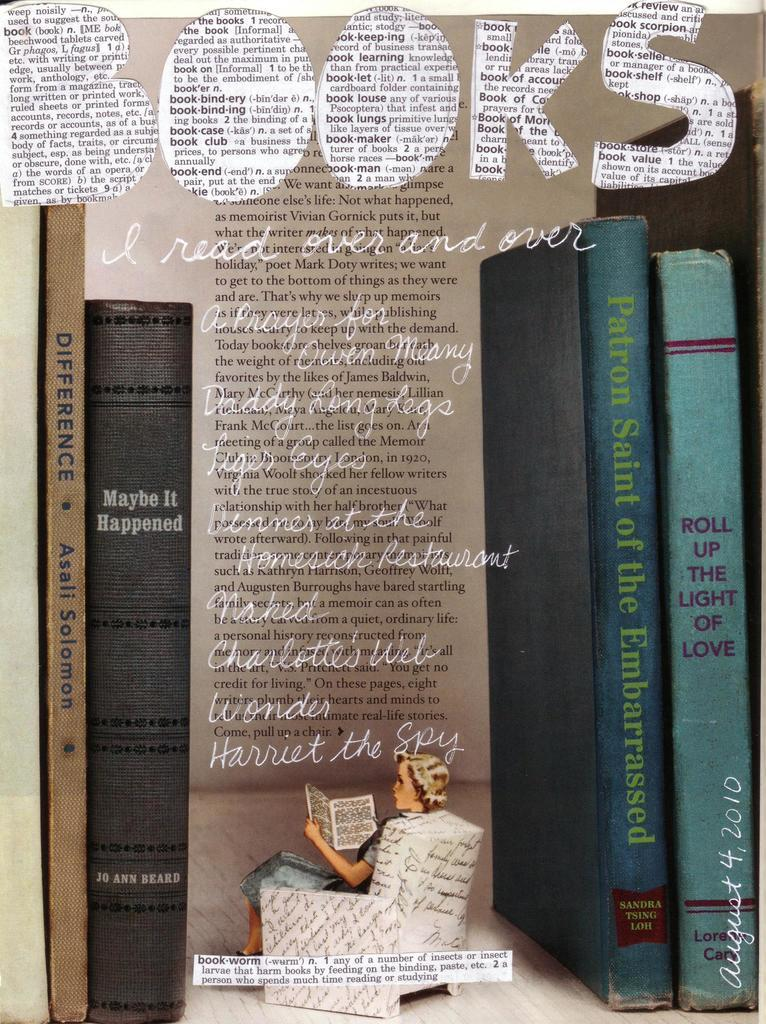<image>
Render a clear and concise summary of the photo. An advertisement showing books and a lady sitting in a chair reading saying Books I Read Over and Over. 